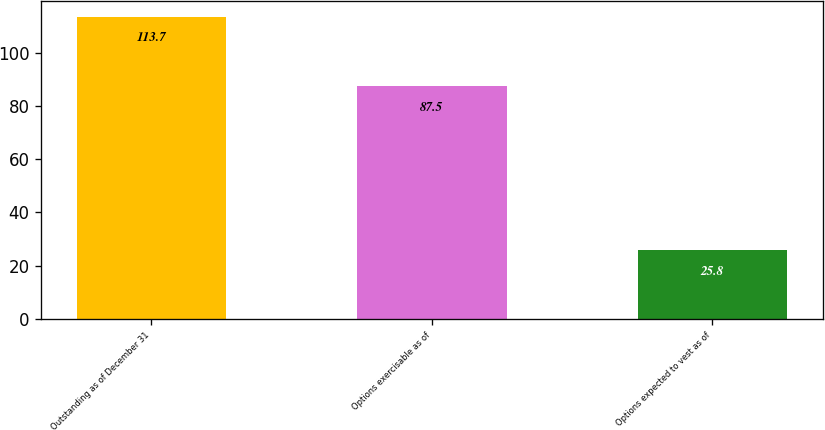<chart> <loc_0><loc_0><loc_500><loc_500><bar_chart><fcel>Outstanding as of December 31<fcel>Options exercisable as of<fcel>Options expected to vest as of<nl><fcel>113.7<fcel>87.5<fcel>25.8<nl></chart> 